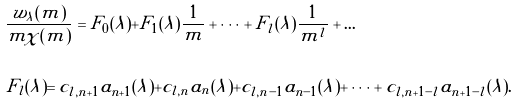Convert formula to latex. <formula><loc_0><loc_0><loc_500><loc_500>& \frac { w _ { \lambda } ( m ) } { m \chi ( m ) } = F _ { 0 } ( \lambda ) + F _ { 1 } ( \lambda ) \frac { 1 } { m } + \dots + F _ { l } ( \lambda ) \frac { 1 } { m ^ { l } } + \dots \\ \ \\ & F _ { l } ( \lambda ) = c _ { l , n + 1 } a _ { n + 1 } ( \lambda ) + c _ { l , n } a _ { n } ( \lambda ) + c _ { l , n - 1 } a _ { n - 1 } ( \lambda ) + \dots + c _ { l , n + 1 - l } a _ { n + 1 - l } ( \lambda ) .</formula> 